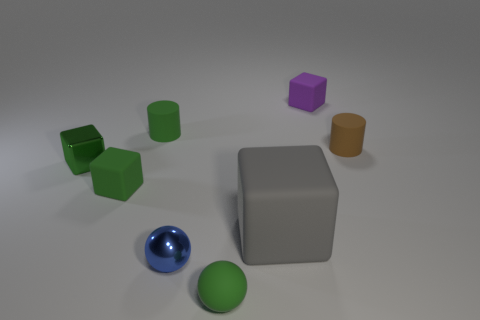What number of things are either small purple metal cubes or small cylinders?
Ensure brevity in your answer.  2. The cylinder to the left of the tiny purple thing is what color?
Ensure brevity in your answer.  Green. What is the size of the green rubber object that is the same shape as the brown thing?
Your response must be concise. Small. How many objects are either purple blocks behind the small green rubber ball or matte objects that are in front of the purple object?
Make the answer very short. 6. There is a object that is both behind the green sphere and in front of the big gray object; what is its size?
Your answer should be compact. Small. There is a purple rubber object; is it the same shape as the metallic thing that is on the right side of the green metal object?
Your answer should be compact. No. What number of objects are shiny objects that are on the right side of the tiny green shiny thing or big blue matte cylinders?
Ensure brevity in your answer.  1. Is the large thing made of the same material as the cylinder that is to the left of the purple rubber object?
Ensure brevity in your answer.  Yes. There is a brown matte object on the right side of the tiny rubber cylinder that is to the left of the small green matte sphere; what shape is it?
Keep it short and to the point. Cylinder. Do the shiny cube and the small matte cylinder that is left of the brown thing have the same color?
Ensure brevity in your answer.  Yes. 